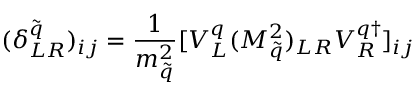Convert formula to latex. <formula><loc_0><loc_0><loc_500><loc_500>( \delta _ { L R } ^ { \tilde { q } } ) _ { i j } = \frac { 1 } { m _ { \tilde { q } } ^ { 2 } } [ V _ { L } ^ { q } ( M _ { \tilde { q } } ^ { 2 } ) _ { L R } V _ { R } ^ { q \dagger } ] _ { i j }</formula> 